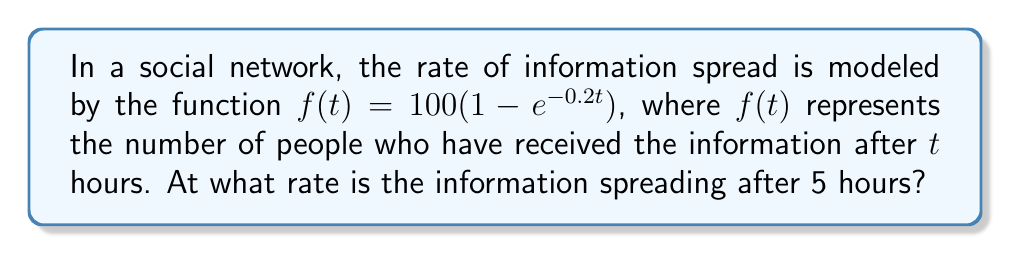What is the answer to this math problem? To find the rate at which the information is spreading after 5 hours, we need to find the derivative of the function $f(t)$ and evaluate it at $t=5$. Let's break this down step-by-step:

1) First, let's recall the derivative of $e^x$ is $e^x$.

2) Now, we'll use the chain rule to find $f'(t)$:

   $f'(t) = 100 \cdot \frac{d}{dt}(1 - e^{-0.2t})$
   $f'(t) = 100 \cdot (-1) \cdot \frac{d}{dt}(e^{-0.2t})$
   $f'(t) = -100 \cdot (e^{-0.2t} \cdot -0.2)$
   $f'(t) = 20e^{-0.2t}$

3) Now that we have the derivative, we can evaluate it at $t=5$:

   $f'(5) = 20e^{-0.2(5)}$
   $f'(5) = 20e^{-1}$

4) We can simplify this further:
   
   $f'(5) = \frac{20}{e} \approx 7.36$

Therefore, after 5 hours, the information is spreading at a rate of approximately 7.36 people per hour.
Answer: $\frac{20}{e}$ people per hour 